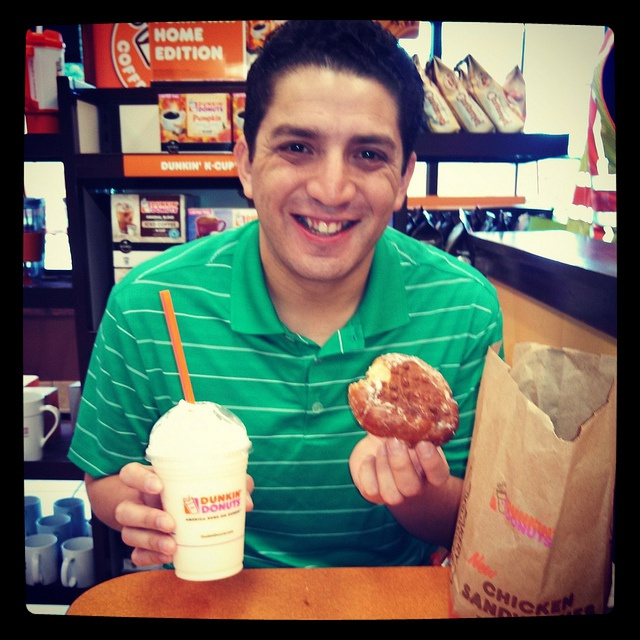Describe the objects in this image and their specific colors. I can see people in black, teal, brown, and navy tones, dining table in black, red, brown, and salmon tones, cup in black, lightyellow, khaki, salmon, and tan tones, donut in black, salmon, brown, and khaki tones, and cup in black, darkgray, navy, gray, and beige tones in this image. 